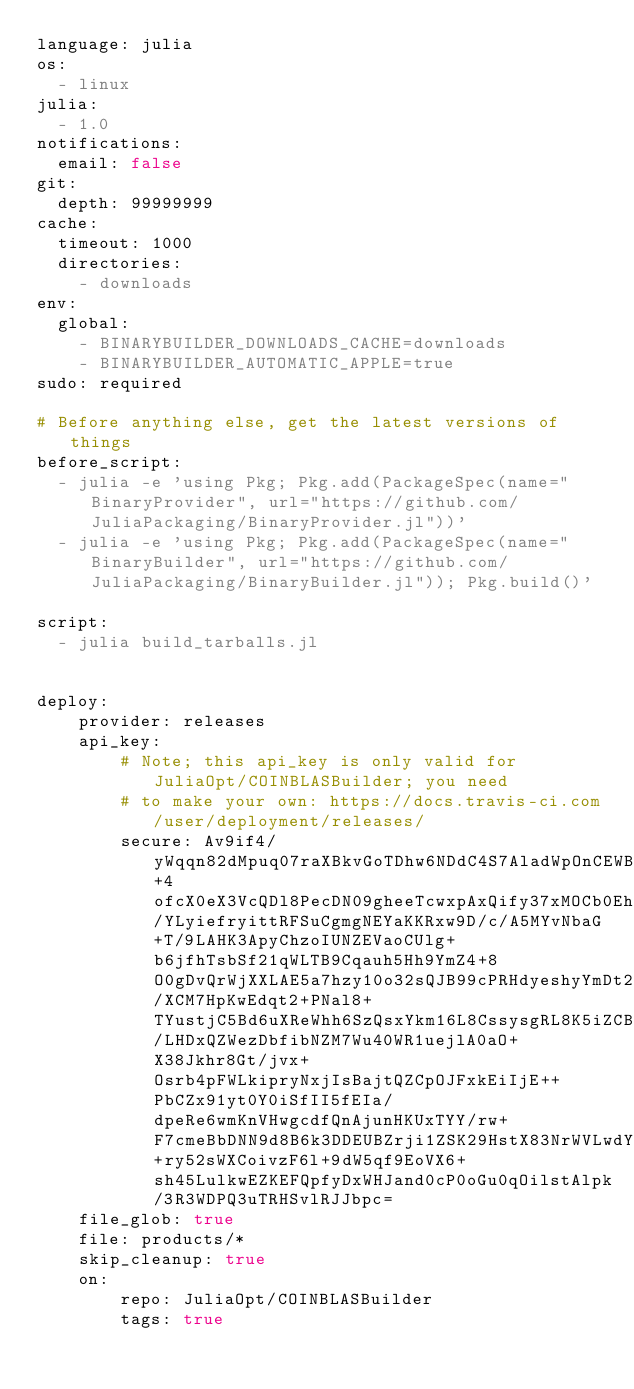<code> <loc_0><loc_0><loc_500><loc_500><_YAML_>language: julia
os:
  - linux
julia:
  - 1.0
notifications:
  email: false
git:
  depth: 99999999
cache:
  timeout: 1000
  directories:
    - downloads
env:
  global:
    - BINARYBUILDER_DOWNLOADS_CACHE=downloads
    - BINARYBUILDER_AUTOMATIC_APPLE=true
sudo: required

# Before anything else, get the latest versions of things
before_script:
  - julia -e 'using Pkg; Pkg.add(PackageSpec(name="BinaryProvider", url="https://github.com/JuliaPackaging/BinaryProvider.jl"))'
  - julia -e 'using Pkg; Pkg.add(PackageSpec(name="BinaryBuilder", url="https://github.com/JuliaPackaging/BinaryBuilder.jl")); Pkg.build()'

script:
  - julia build_tarballs.jl


deploy:
    provider: releases
    api_key:
        # Note; this api_key is only valid for JuliaOpt/COINBLASBuilder; you need
        # to make your own: https://docs.travis-ci.com/user/deployment/releases/
        secure: Av9if4/yWqqn82dMpuq07raXBkvGoTDhw6NDdC4S7AladWpOnCEWBSmlyv1Rnapmqpdis3KDPrZP3xJXrlWlBiPWK+4ofcX0eX3VcQDl8PecDN09gheeTcwxpAxQify37xMOCb0EhSNu0a/YLyiefryittRFSuCgmgNEYaKKRxw9D/c/A5MYvNbaG+T/9LAHK3ApyChzoIUNZEVaoCUlg+b6jfhTsbSf21qWLTB9Cqauh5Hh9YmZ4+8O0gDvQrWjXXLAE5a7hzy10o32sQJB99cPRHdyeshyYmDt2m6Gwk/XCM7HpKwEdqt2+PNal8+TYustjC5Bd6uXReWhh6SzQsxYkm16L8CssysgRL8K5iZCBVrkwIOskJBMm3c/LHDxQZWezDbfibNZM7Wu40WR1uejlA0aO+X38Jkhr8Gt/jvx+Osrb4pFWLkipryNxjIsBajtQZCpOJFxkEiIjE++PbCZx91yt0Y0iSfII5fEIa/dpeRe6wmKnVHwgcdfQnAjunHKUxTYY/rw+F7cmeBbDNN9d8B6k3DDEUBZrji1ZSK29HstX83NrWVLwdY514jcbcAcWK8r41g+ry52sWXCoivzF6l+9dW5qf9EoVX6+sh45LulkwEZKEFQpfyDxWHJand0cP0oGu0qOilstAlpk/3R3WDPQ3uTRHSvlRJJbpc=
    file_glob: true
    file: products/*
    skip_cleanup: true
    on:
        repo: JuliaOpt/COINBLASBuilder
        tags: true
</code> 